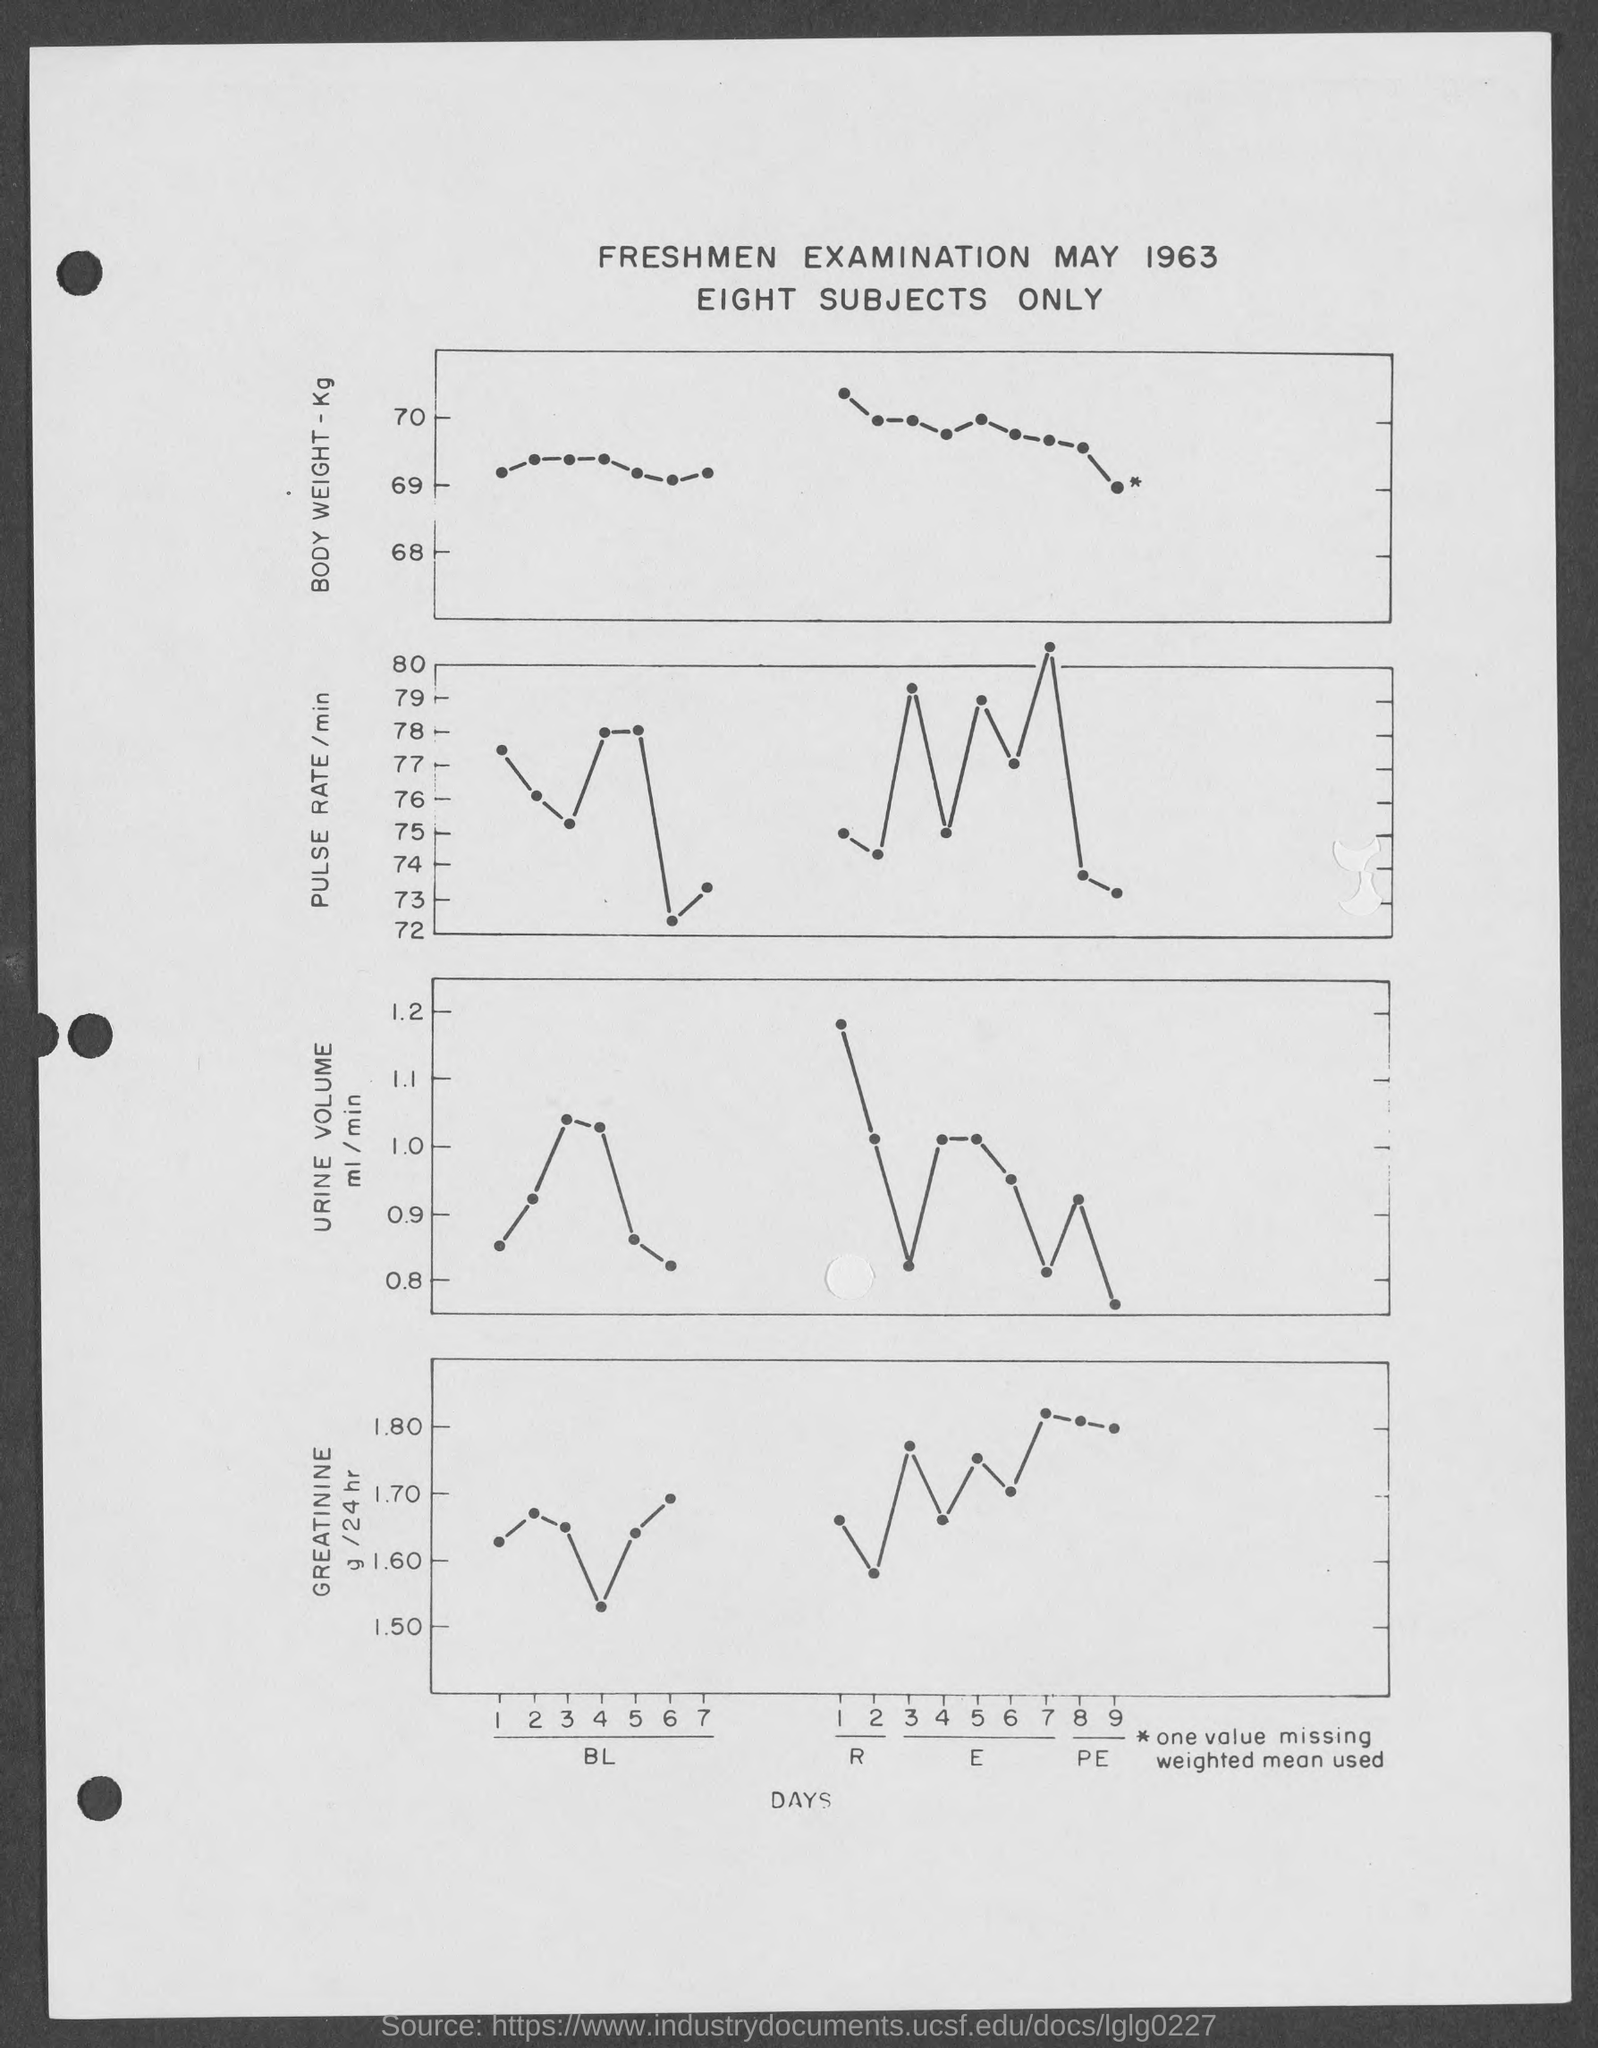What is the title?
Your answer should be compact. Freshmen examination may 1963. The examination is of which year?
Your response must be concise. 1963. What does the y axis represent in the first chart from top?
Offer a terse response. Body weight. 